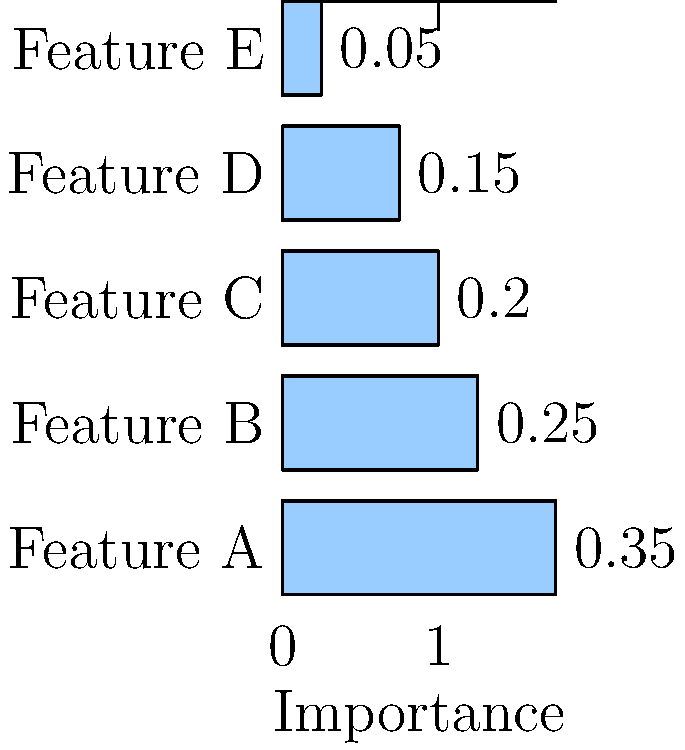Based on the horizontal bar plot showing feature importance in a random forest model, which feature has the highest importance, and what is its corresponding importance value? How does this information relate to the concept of cross-referencing in machine learning analysis? To answer this question, we need to analyze the horizontal bar plot and understand the concept of feature importance in random forest models. Let's break it down step-by-step:

1. Examine the plot:
   The plot shows five features (A, B, C, D, and E) with their corresponding importance values represented by horizontal bars.

2. Identify the longest bar:
   The longest bar corresponds to the feature with the highest importance.
   In this case, Feature A has the longest bar.

3. Read the importance value:
   The importance value for Feature A is 0.35, which is the highest among all features.

4. Understand feature importance:
   In random forest models, feature importance indicates how much a particular feature contributes to the model's predictions.
   Higher values suggest that the feature has a greater impact on the model's decision-making process.

5. Relate to cross-referencing:
   Cross-referencing in machine learning analysis involves comparing and validating information from multiple sources or methods. In this context, we can:
   a) Compare the importance of different features to understand their relative contributions.
   b) Cross-reference this information with domain knowledge to validate if the importance aligns with expert expectations.
   c) Use this information to guide feature selection or engineering in future iterations of the model.

6. Consider other features:
   While Feature A is the most important, it's valuable to note the importance of other features as well:
   Feature B: 0.25
   Feature C: 0.20
   Feature D: 0.15
   Feature E: 0.05
   This information can be cross-referenced with other analysis techniques to gain a comprehensive understanding of feature relevance.

By analyzing this plot and understanding its implications, we can make informed decisions about feature selection, model interpretation, and potential areas for further investigation in our machine learning pipeline.
Answer: Feature A, with an importance value of 0.35. 